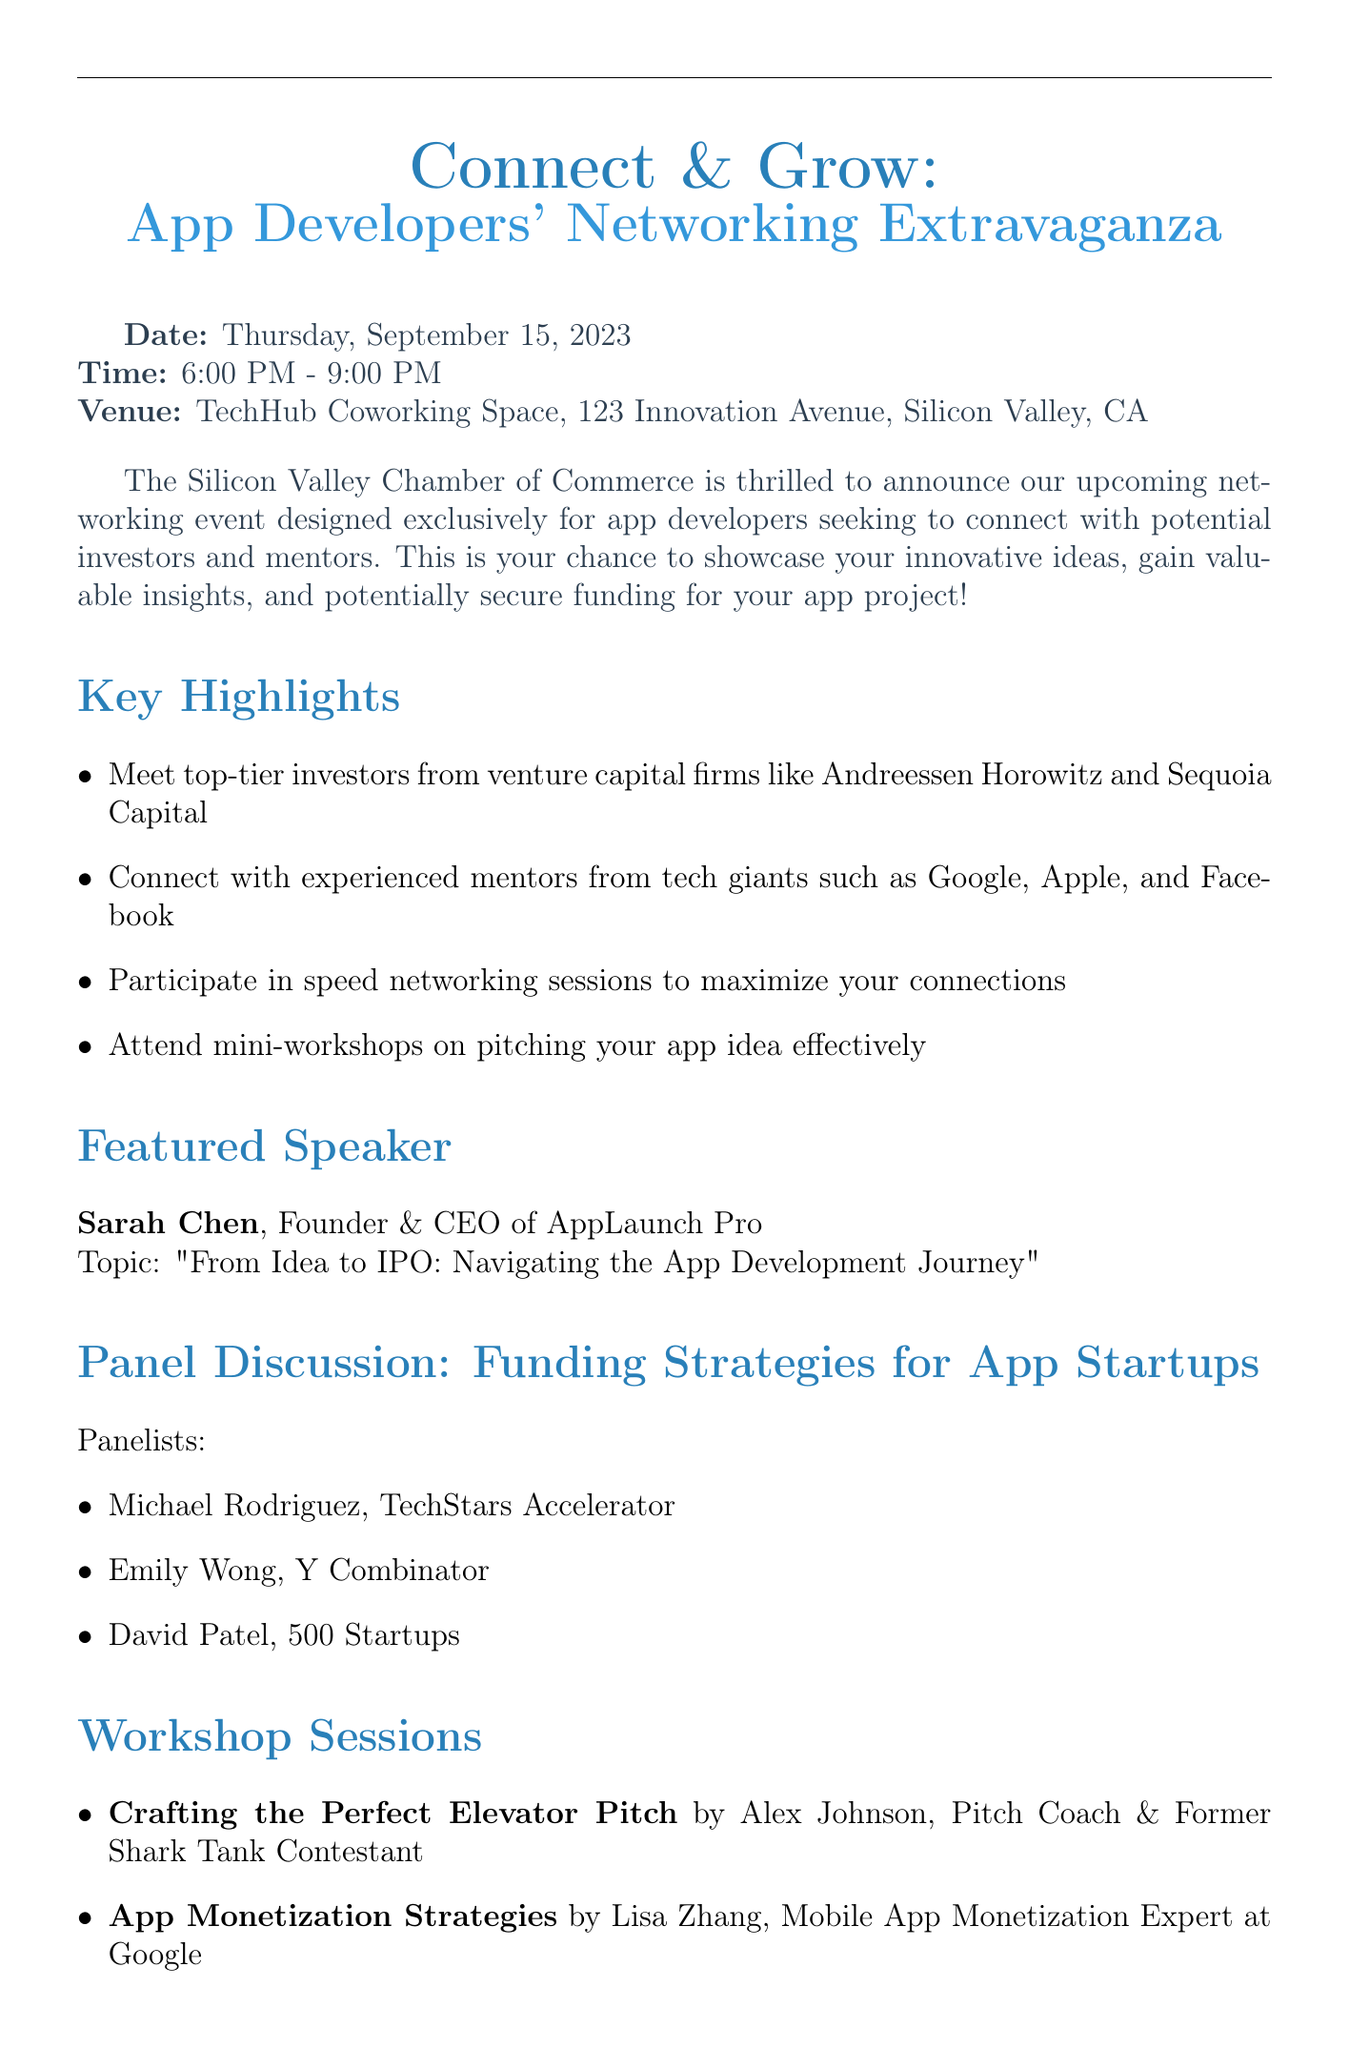What is the date of the event? The date is specified in the event details section of the document.
Answer: Thursday, September 15, 2023 What time does the event start? The starting time is given under the event details section.
Answer: 6:00 PM Who is the featured speaker? The featured speaker's name and title are listed in the section dedicated to the featured speaker.
Answer: Sarah Chen What company does Michael Rodriguez represent? Michael Rodriguez's company is mentioned in the panel discussion section.
Answer: TechStars Accelerator What is the registration deadline? The registration deadline is clearly stated in the registration information section.
Answer: September 8, 2023 How much is the registration fee for non-members? The fee for non-members is mentioned in the registration information section.
Answer: $100 Which company is sponsoring the event? Sponsors are listed in their own section, indicating potential supporters of the event.
Answer: Amazon Web Services What type of sessions are offered for networking? The networking opportunities section outlines various types of sessions available.
Answer: One-on-one sessions with investors What will the workshop by Alex Johnson cover? The title and presenter of the workshop provide the topic it will cover.
Answer: Crafting the Perfect Elevator Pitch 